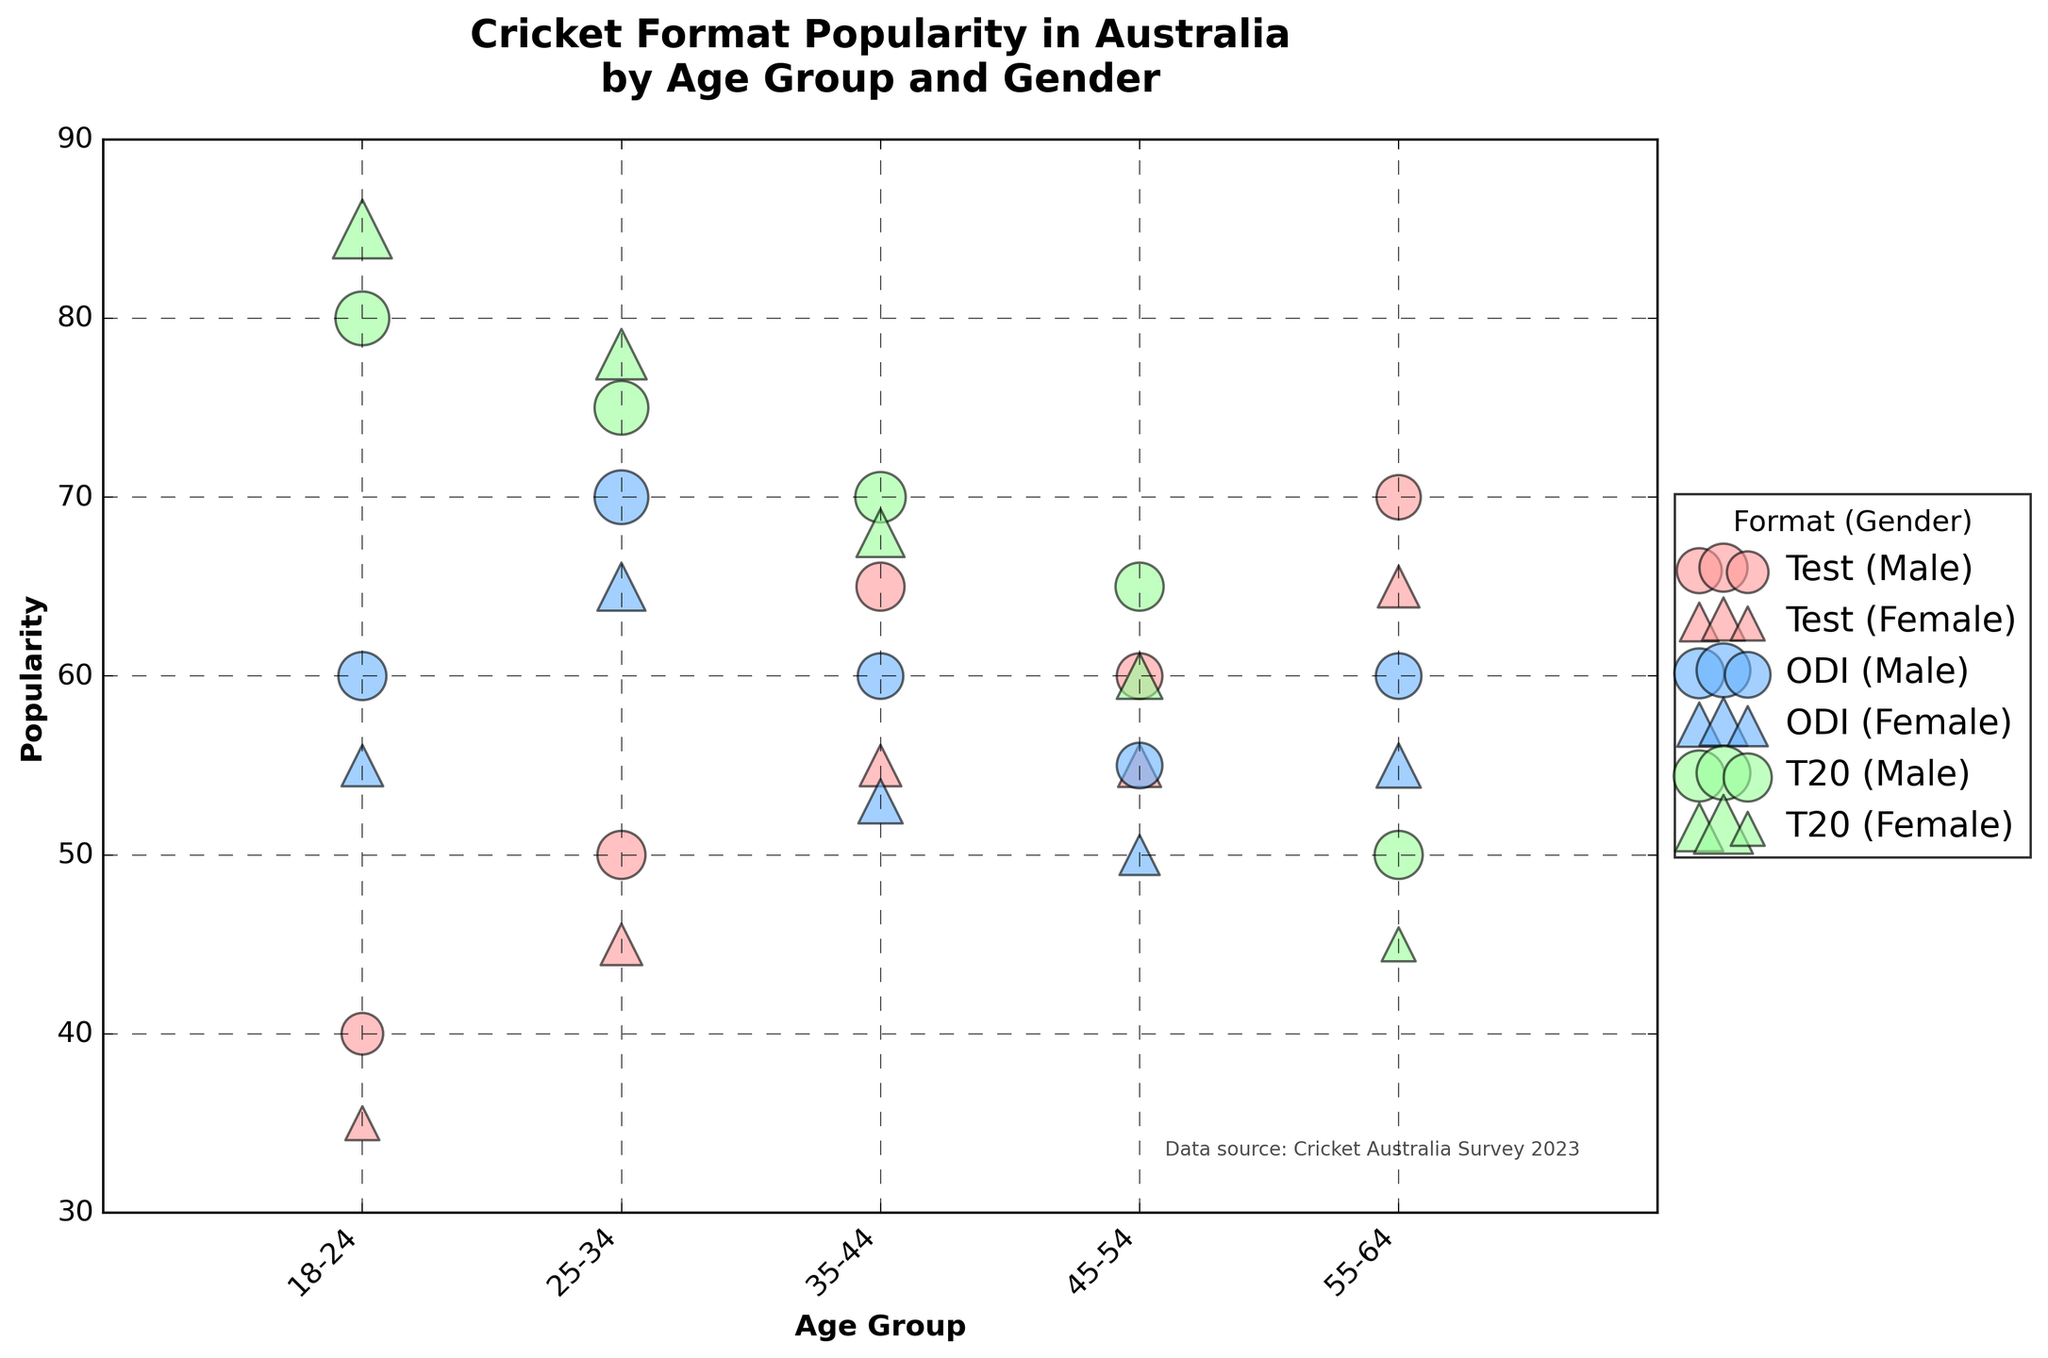What is the title of the figure? The title of the figure is usually found at the top and describes what the figure is about. In this case, it is "Cricket Format Popularity in Australia by Age Group and Gender".
Answer: Cricket Format Popularity in Australia by Age Group and Gender What is the most popular cricket format among 18-24-year-old females? To determine the most popular format, look for the highest popularity value among 18-24-year-old females. The highest value for females in this group is in the T20 format, with a popularity of 85.
Answer: T20 How does the popularity of Test cricket among males in the 25-34 age group compare to that in the 35-44 age group? Compare the popularity values for Test cricket among males in these age groups. For 25-34 it is 50, and for 35-44 it is 65.
Answer: 35-44 is higher Which gender has a higher interest in ODI cricket within the 55-64 age group? Look at the popularity values for ODI cricket within the 55-64 age group for both males and females. Males have a popularity of 60, while females have 55.
Answer: Male What age group does the smallest bubble represent in the T20 format for females? To identify the smallest bubble, check the bubble sizes for females in the T20 format across different age groups. The smallest bubble has a size of 10, which corresponds to the 55-64 age group.
Answer: 55-64 What is the popularity range of Test cricket among all age groups for both males and females? Identify the minimum and maximum popularity values for Test cricket across all age groups and both genders. The range is from the lowest value of 35 to the highest value of 70.
Answer: 35 to 70 How does the popularity of ODI cricket change with age for male participants? Look at the popularity values for ODI cricket for males across different age groups: 18-24 (60), 25-34 (70), 35-44 (60), 45-54 (55), 55-64 (60). The pattern shows fluctuations but peaks at 25-34.
Answer: Peaks at 25-34, fluctuates Is the popularity of T20 cricket generally higher among females than males? Compare the popularity of T20 cricket for each age group between males and females. Except for the 55-64 age group, females have consistently higher values.
Answer: Yes, generally higher What's the average popularity of ODI cricket for females across all age groups? Compute the average of the popularity values for females in ODI cricket across all age groups: (55+65+53+50+55)/5 = 55.6.
Answer: 55.6 Between males and females in the 35-44 age group, who prefers Test cricket more? Compare the popularity values for Test cricket between males and females in the 35-44 age group. Males have a value of 65, while females have 55.
Answer: Males 